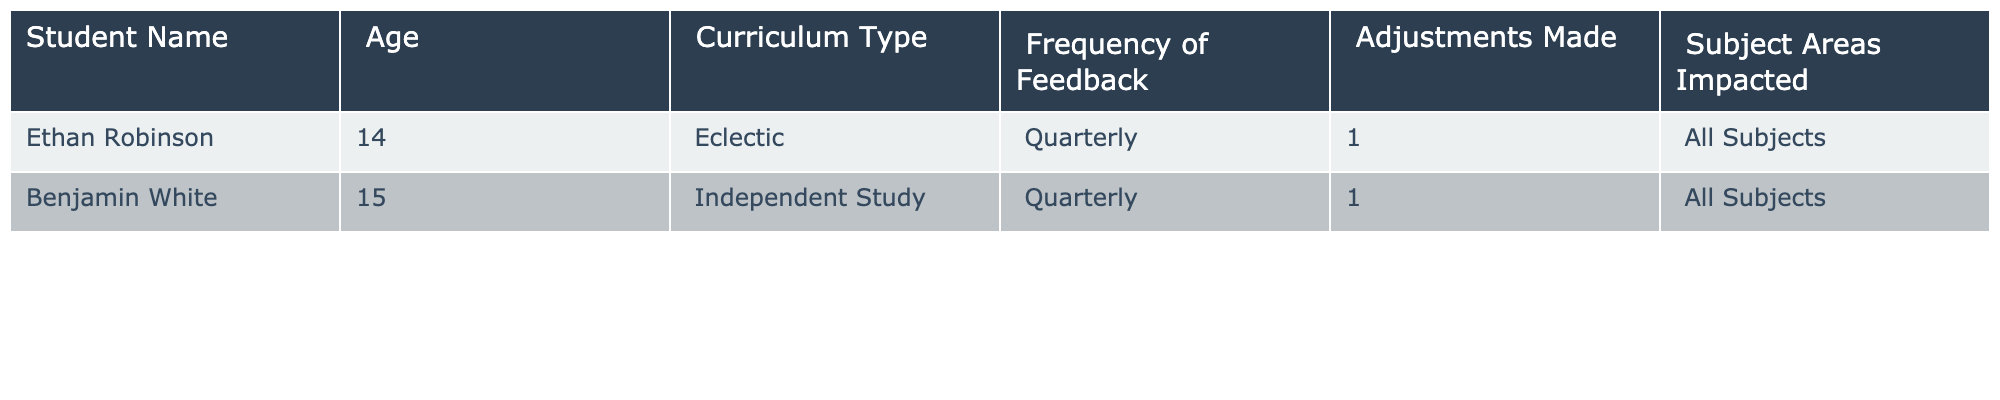What are the names of the students in the table? The table lists two students: Ethan Robinson and Benjamin White.
Answer: Ethan Robinson, Benjamin White How often do both students provide feedback on their curriculum? Both students provide feedback quarterly, as indicated in the frequency of feedback column.
Answer: Quarterly What types of curricula are used by the students? Ethan Robinson uses an Eclectic curriculum, while Benjamin White uses Independent Study.
Answer: Eclectic, Independent Study How many adjustments were made based on student feedback? Each student had 1 adjustment made based on the feedback they provided.
Answer: 1 Which subject areas were impacted by the adjustments? All subjects were impacted for both students, as shown in the subject areas impacted column.
Answer: All Subjects Is there any student who provides feedback more frequently than quarterly? No, both students provide feedback quarterly, and there are no entries for more frequent feedback.
Answer: No What is the average number of adjustments made per student? There are 2 students and a total of 2 adjustments made (1 for each student). The average is 2/2 = 1.
Answer: 1 If a new student reports quarterly feedback with 2 adjustments, what would be the new average number of adjustments? If we add the new student with 2 adjustments, the total number of adjustments becomes 4 (1 + 1 + 2), and the average for 3 students is 4/3 = 1.33.
Answer: 1.33 How many students reported an adjustment made in "All Subjects"? Both students reported adjustments made in all subjects, so the total is 2.
Answer: 2 Would any of the students need to change their curriculum type if more frequent feedback is required? No, as their current feedback frequency is quarterly. There is no indication they need to change.
Answer: No 